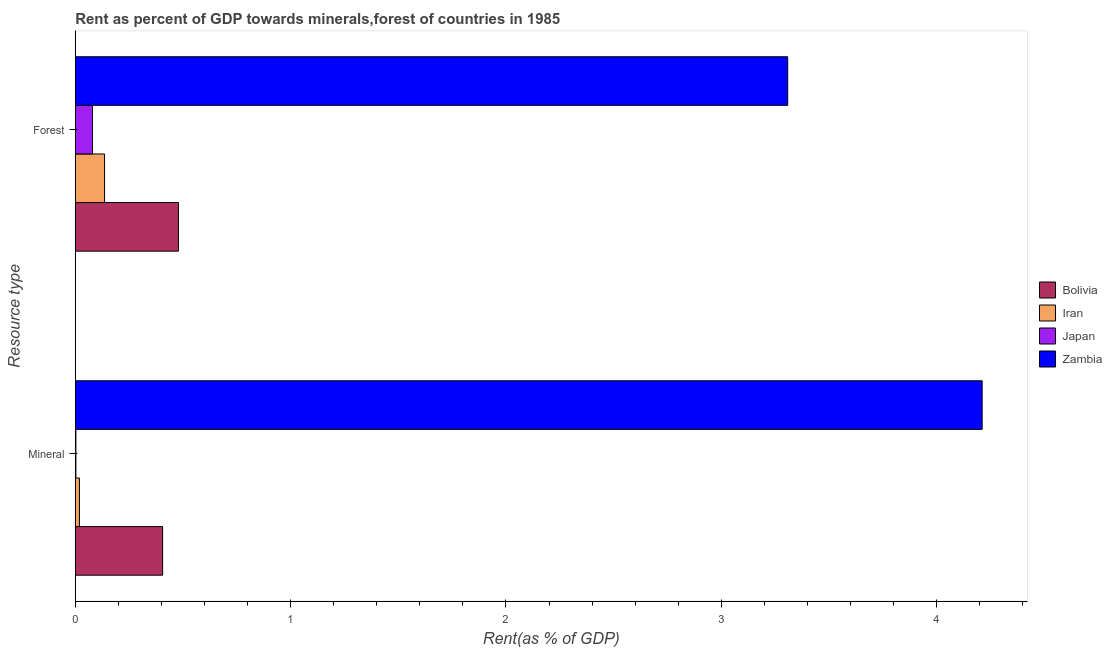How many different coloured bars are there?
Make the answer very short. 4. Are the number of bars on each tick of the Y-axis equal?
Ensure brevity in your answer.  Yes. How many bars are there on the 2nd tick from the bottom?
Provide a short and direct response. 4. What is the label of the 1st group of bars from the top?
Provide a succinct answer. Forest. What is the forest rent in Japan?
Offer a terse response. 0.08. Across all countries, what is the maximum forest rent?
Provide a short and direct response. 3.31. Across all countries, what is the minimum mineral rent?
Offer a terse response. 0. In which country was the mineral rent maximum?
Keep it short and to the point. Zambia. What is the total mineral rent in the graph?
Your answer should be compact. 4.64. What is the difference between the forest rent in Japan and that in Bolivia?
Make the answer very short. -0.4. What is the difference between the forest rent in Japan and the mineral rent in Bolivia?
Make the answer very short. -0.33. What is the average forest rent per country?
Give a very brief answer. 1. What is the difference between the forest rent and mineral rent in Zambia?
Offer a very short reply. -0.9. In how many countries, is the mineral rent greater than 2.2 %?
Provide a succinct answer. 1. What is the ratio of the forest rent in Japan to that in Iran?
Your answer should be very brief. 0.59. What does the 1st bar from the top in Mineral represents?
Your answer should be compact. Zambia. What does the 4th bar from the bottom in Forest represents?
Make the answer very short. Zambia. How many bars are there?
Provide a short and direct response. 8. Are all the bars in the graph horizontal?
Provide a short and direct response. Yes. How many countries are there in the graph?
Offer a terse response. 4. Are the values on the major ticks of X-axis written in scientific E-notation?
Your answer should be compact. No. Does the graph contain grids?
Give a very brief answer. No. How many legend labels are there?
Your answer should be very brief. 4. What is the title of the graph?
Provide a short and direct response. Rent as percent of GDP towards minerals,forest of countries in 1985. Does "Lebanon" appear as one of the legend labels in the graph?
Keep it short and to the point. No. What is the label or title of the X-axis?
Your answer should be compact. Rent(as % of GDP). What is the label or title of the Y-axis?
Keep it short and to the point. Resource type. What is the Rent(as % of GDP) of Bolivia in Mineral?
Provide a succinct answer. 0.41. What is the Rent(as % of GDP) in Iran in Mineral?
Your answer should be very brief. 0.02. What is the Rent(as % of GDP) of Japan in Mineral?
Offer a terse response. 0. What is the Rent(as % of GDP) of Zambia in Mineral?
Your answer should be compact. 4.21. What is the Rent(as % of GDP) in Bolivia in Forest?
Ensure brevity in your answer.  0.48. What is the Rent(as % of GDP) in Iran in Forest?
Offer a terse response. 0.14. What is the Rent(as % of GDP) of Japan in Forest?
Offer a terse response. 0.08. What is the Rent(as % of GDP) in Zambia in Forest?
Keep it short and to the point. 3.31. Across all Resource type, what is the maximum Rent(as % of GDP) of Bolivia?
Offer a terse response. 0.48. Across all Resource type, what is the maximum Rent(as % of GDP) of Iran?
Offer a terse response. 0.14. Across all Resource type, what is the maximum Rent(as % of GDP) of Japan?
Your answer should be compact. 0.08. Across all Resource type, what is the maximum Rent(as % of GDP) in Zambia?
Your answer should be very brief. 4.21. Across all Resource type, what is the minimum Rent(as % of GDP) in Bolivia?
Offer a very short reply. 0.41. Across all Resource type, what is the minimum Rent(as % of GDP) in Iran?
Your response must be concise. 0.02. Across all Resource type, what is the minimum Rent(as % of GDP) in Japan?
Provide a short and direct response. 0. Across all Resource type, what is the minimum Rent(as % of GDP) in Zambia?
Offer a very short reply. 3.31. What is the total Rent(as % of GDP) in Bolivia in the graph?
Give a very brief answer. 0.88. What is the total Rent(as % of GDP) in Iran in the graph?
Provide a short and direct response. 0.16. What is the total Rent(as % of GDP) in Japan in the graph?
Keep it short and to the point. 0.08. What is the total Rent(as % of GDP) of Zambia in the graph?
Your answer should be compact. 7.52. What is the difference between the Rent(as % of GDP) in Bolivia in Mineral and that in Forest?
Give a very brief answer. -0.07. What is the difference between the Rent(as % of GDP) of Iran in Mineral and that in Forest?
Provide a short and direct response. -0.12. What is the difference between the Rent(as % of GDP) of Japan in Mineral and that in Forest?
Provide a short and direct response. -0.08. What is the difference between the Rent(as % of GDP) of Zambia in Mineral and that in Forest?
Give a very brief answer. 0.9. What is the difference between the Rent(as % of GDP) of Bolivia in Mineral and the Rent(as % of GDP) of Iran in Forest?
Offer a terse response. 0.27. What is the difference between the Rent(as % of GDP) in Bolivia in Mineral and the Rent(as % of GDP) in Japan in Forest?
Offer a terse response. 0.33. What is the difference between the Rent(as % of GDP) of Bolivia in Mineral and the Rent(as % of GDP) of Zambia in Forest?
Offer a terse response. -2.9. What is the difference between the Rent(as % of GDP) of Iran in Mineral and the Rent(as % of GDP) of Japan in Forest?
Your answer should be compact. -0.06. What is the difference between the Rent(as % of GDP) of Iran in Mineral and the Rent(as % of GDP) of Zambia in Forest?
Your response must be concise. -3.29. What is the difference between the Rent(as % of GDP) in Japan in Mineral and the Rent(as % of GDP) in Zambia in Forest?
Offer a terse response. -3.31. What is the average Rent(as % of GDP) in Bolivia per Resource type?
Offer a very short reply. 0.44. What is the average Rent(as % of GDP) of Iran per Resource type?
Make the answer very short. 0.08. What is the average Rent(as % of GDP) of Japan per Resource type?
Offer a very short reply. 0.04. What is the average Rent(as % of GDP) of Zambia per Resource type?
Your answer should be compact. 3.76. What is the difference between the Rent(as % of GDP) of Bolivia and Rent(as % of GDP) of Iran in Mineral?
Your response must be concise. 0.39. What is the difference between the Rent(as % of GDP) of Bolivia and Rent(as % of GDP) of Japan in Mineral?
Your response must be concise. 0.4. What is the difference between the Rent(as % of GDP) in Bolivia and Rent(as % of GDP) in Zambia in Mineral?
Offer a very short reply. -3.81. What is the difference between the Rent(as % of GDP) in Iran and Rent(as % of GDP) in Japan in Mineral?
Your answer should be very brief. 0.02. What is the difference between the Rent(as % of GDP) in Iran and Rent(as % of GDP) in Zambia in Mineral?
Offer a terse response. -4.19. What is the difference between the Rent(as % of GDP) of Japan and Rent(as % of GDP) of Zambia in Mineral?
Give a very brief answer. -4.21. What is the difference between the Rent(as % of GDP) in Bolivia and Rent(as % of GDP) in Iran in Forest?
Keep it short and to the point. 0.34. What is the difference between the Rent(as % of GDP) of Bolivia and Rent(as % of GDP) of Japan in Forest?
Your response must be concise. 0.4. What is the difference between the Rent(as % of GDP) in Bolivia and Rent(as % of GDP) in Zambia in Forest?
Give a very brief answer. -2.83. What is the difference between the Rent(as % of GDP) of Iran and Rent(as % of GDP) of Japan in Forest?
Give a very brief answer. 0.06. What is the difference between the Rent(as % of GDP) of Iran and Rent(as % of GDP) of Zambia in Forest?
Provide a short and direct response. -3.17. What is the difference between the Rent(as % of GDP) of Japan and Rent(as % of GDP) of Zambia in Forest?
Provide a succinct answer. -3.23. What is the ratio of the Rent(as % of GDP) of Bolivia in Mineral to that in Forest?
Make the answer very short. 0.85. What is the ratio of the Rent(as % of GDP) in Iran in Mineral to that in Forest?
Offer a terse response. 0.14. What is the ratio of the Rent(as % of GDP) of Japan in Mineral to that in Forest?
Ensure brevity in your answer.  0.03. What is the ratio of the Rent(as % of GDP) in Zambia in Mineral to that in Forest?
Offer a very short reply. 1.27. What is the difference between the highest and the second highest Rent(as % of GDP) of Bolivia?
Provide a succinct answer. 0.07. What is the difference between the highest and the second highest Rent(as % of GDP) of Iran?
Offer a terse response. 0.12. What is the difference between the highest and the second highest Rent(as % of GDP) in Japan?
Make the answer very short. 0.08. What is the difference between the highest and the second highest Rent(as % of GDP) in Zambia?
Provide a succinct answer. 0.9. What is the difference between the highest and the lowest Rent(as % of GDP) of Bolivia?
Your answer should be very brief. 0.07. What is the difference between the highest and the lowest Rent(as % of GDP) of Iran?
Ensure brevity in your answer.  0.12. What is the difference between the highest and the lowest Rent(as % of GDP) of Japan?
Ensure brevity in your answer.  0.08. What is the difference between the highest and the lowest Rent(as % of GDP) in Zambia?
Offer a very short reply. 0.9. 